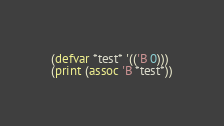<code> <loc_0><loc_0><loc_500><loc_500><_Lisp_>(defvar *test* '(('B 0)))
(print (assoc 'B *test*))
</code> 